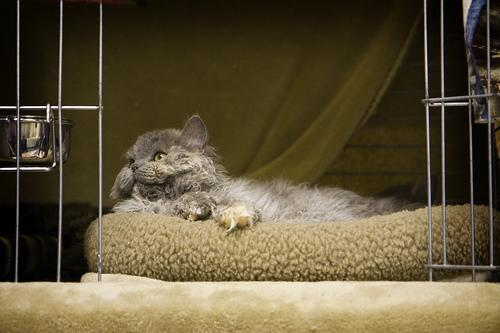What type of animal is in this cage?

Choices:
A) reptile
B) domestic
C) flying
D) wild domestic 